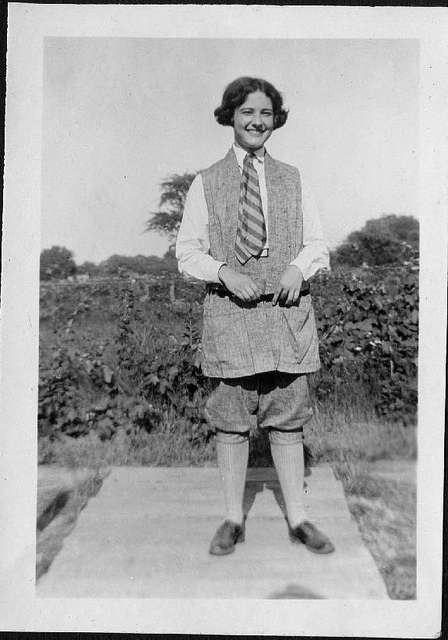<image>What sport is the woman playing? I don't know what sport the woman is playing. It could be tennis, horseback riding, golf or she might not be playing any sport. What sport is the woman playing? I don't know what sport the woman is playing. It can be tennis, horseback riding, or golf. 